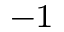Convert formula to latex. <formula><loc_0><loc_0><loc_500><loc_500>^ { - 1 }</formula> 